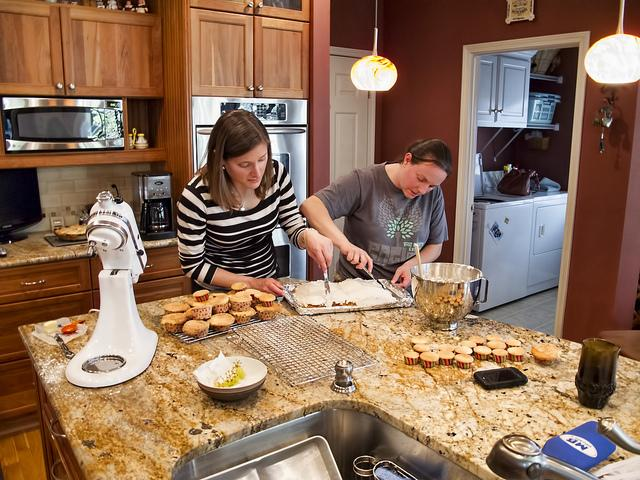What have these ladies been doing? Please explain your reasoning. baking. The ladies have out a mixer, bowl, wire racks for cooling, and unfrosted cupcakes. they are currently in the process of frosting their homemade treats. 